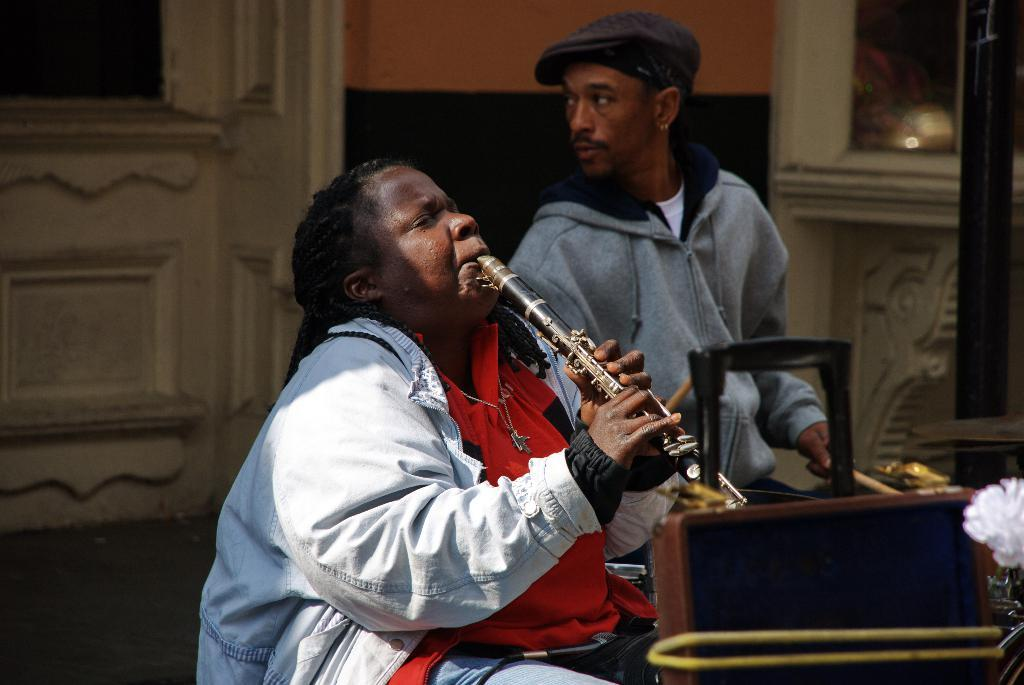What is the person in the image doing? The person in the image is sitting and playing a musical instrument. Can you describe the other person in the image? There is a man playing a band in the image. What can be seen in the background of the image? There is a wall and a door in the background of the image. How does the bit affect the pollution in the image? There is no mention of a bit or pollution in the image, so it is not possible to answer that question. 